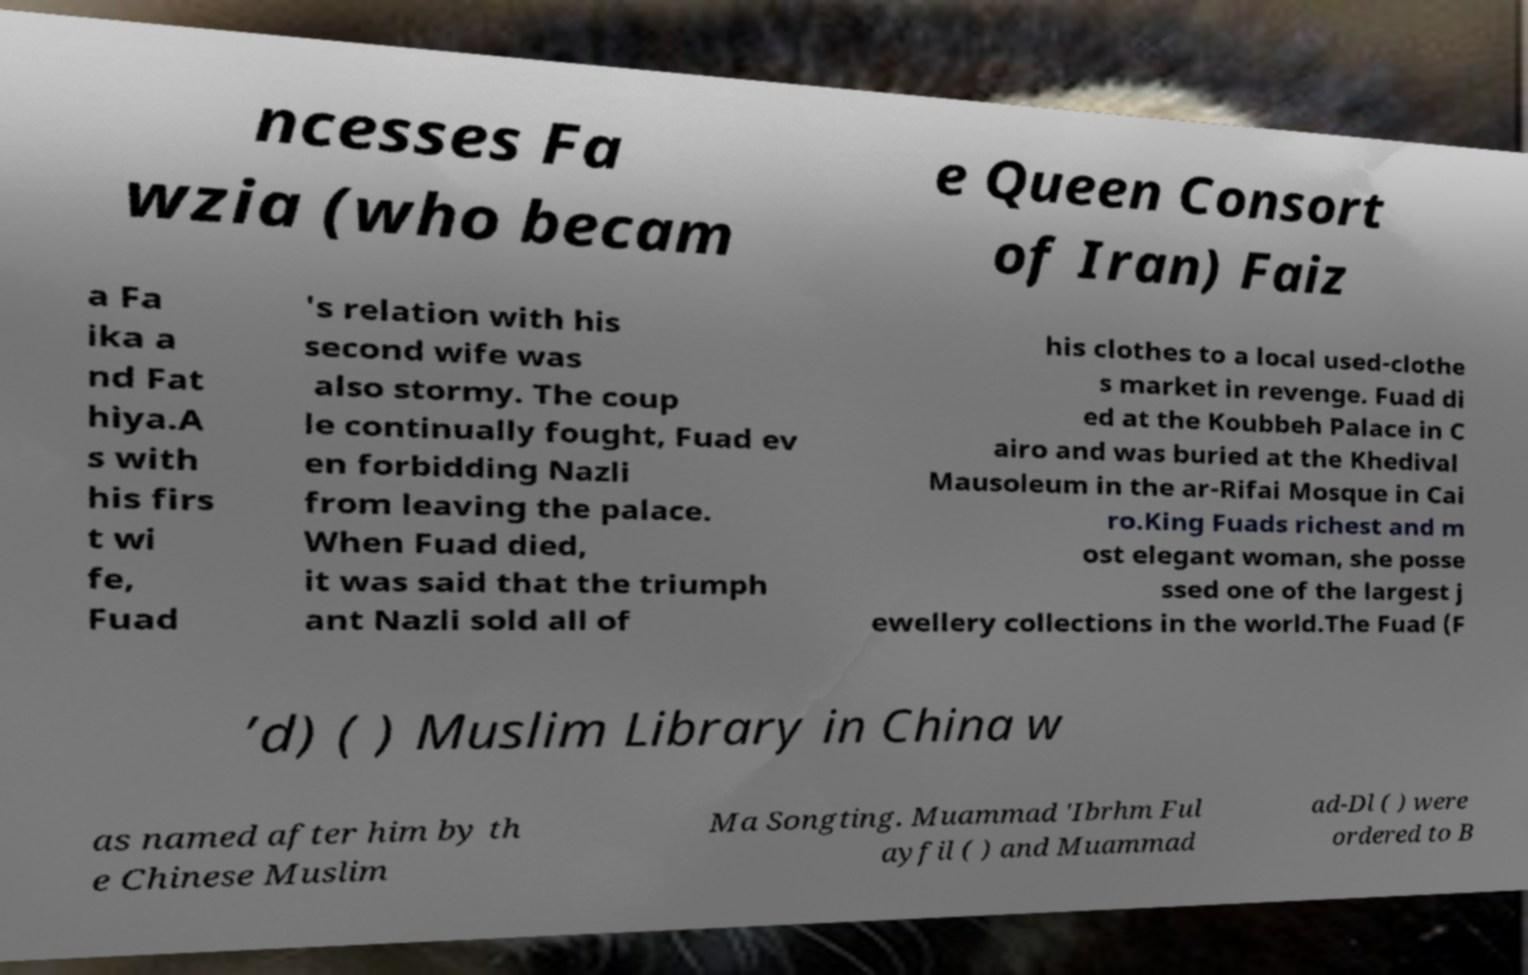For documentation purposes, I need the text within this image transcribed. Could you provide that? ncesses Fa wzia (who becam e Queen Consort of Iran) Faiz a Fa ika a nd Fat hiya.A s with his firs t wi fe, Fuad 's relation with his second wife was also stormy. The coup le continually fought, Fuad ev en forbidding Nazli from leaving the palace. When Fuad died, it was said that the triumph ant Nazli sold all of his clothes to a local used-clothe s market in revenge. Fuad di ed at the Koubbeh Palace in C airo and was buried at the Khedival Mausoleum in the ar-Rifai Mosque in Cai ro.King Fuads richest and m ost elegant woman, she posse ssed one of the largest j ewellery collections in the world.The Fuad (F ’d) ( ) Muslim Library in China w as named after him by th e Chinese Muslim Ma Songting. Muammad 'Ibrhm Ful ayfil ( ) and Muammad ad-Dl ( ) were ordered to B 